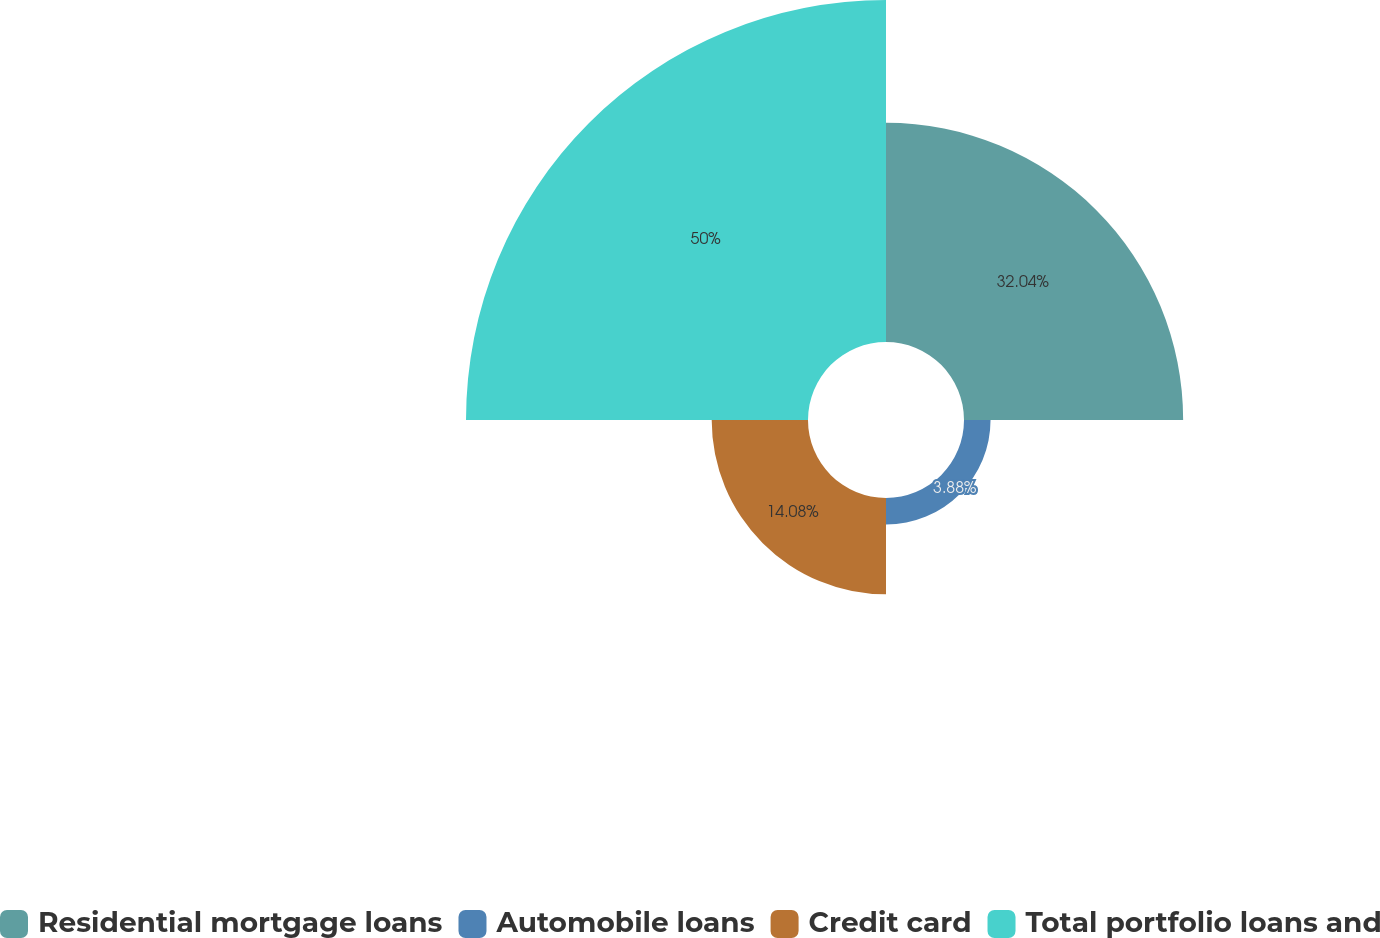<chart> <loc_0><loc_0><loc_500><loc_500><pie_chart><fcel>Residential mortgage loans<fcel>Automobile loans<fcel>Credit card<fcel>Total portfolio loans and<nl><fcel>32.04%<fcel>3.88%<fcel>14.08%<fcel>50.0%<nl></chart> 